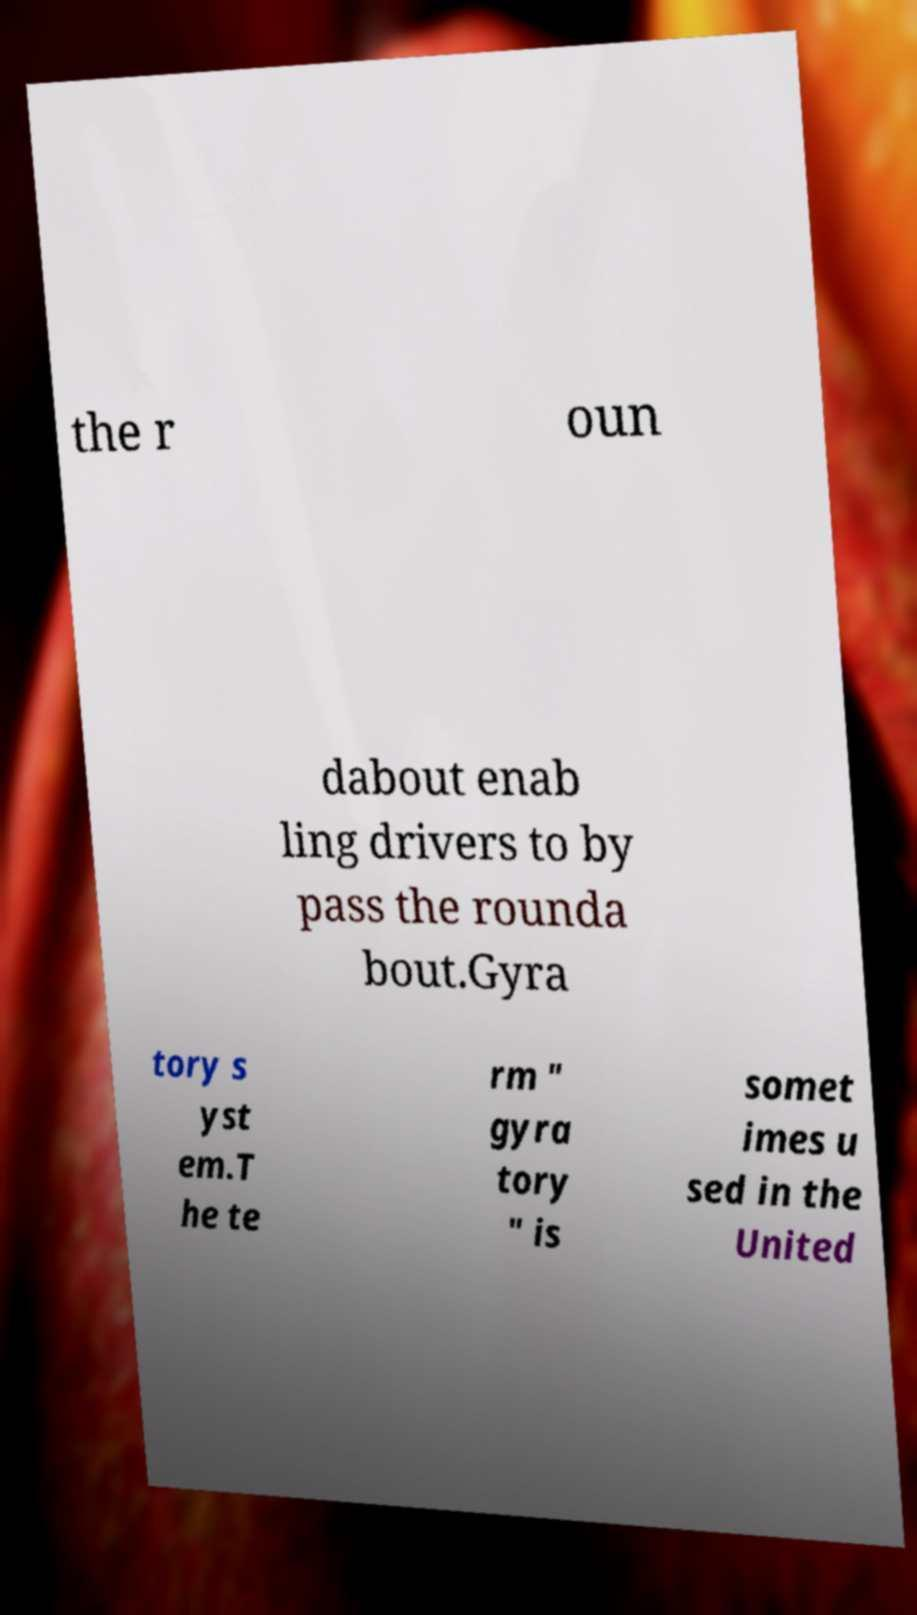Please identify and transcribe the text found in this image. the r oun dabout enab ling drivers to by pass the rounda bout.Gyra tory s yst em.T he te rm " gyra tory " is somet imes u sed in the United 